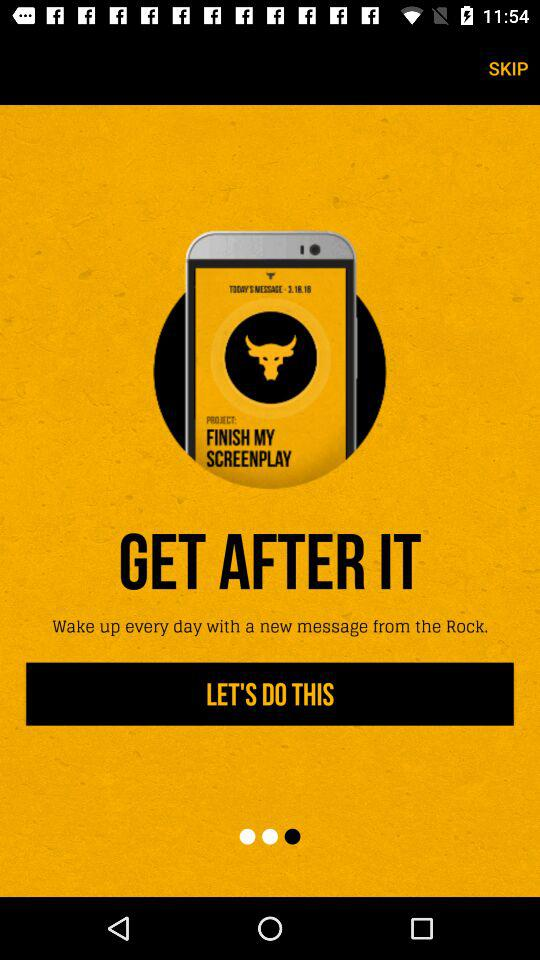Which version of the application is this?
When the provided information is insufficient, respond with <no answer>. <no answer> 